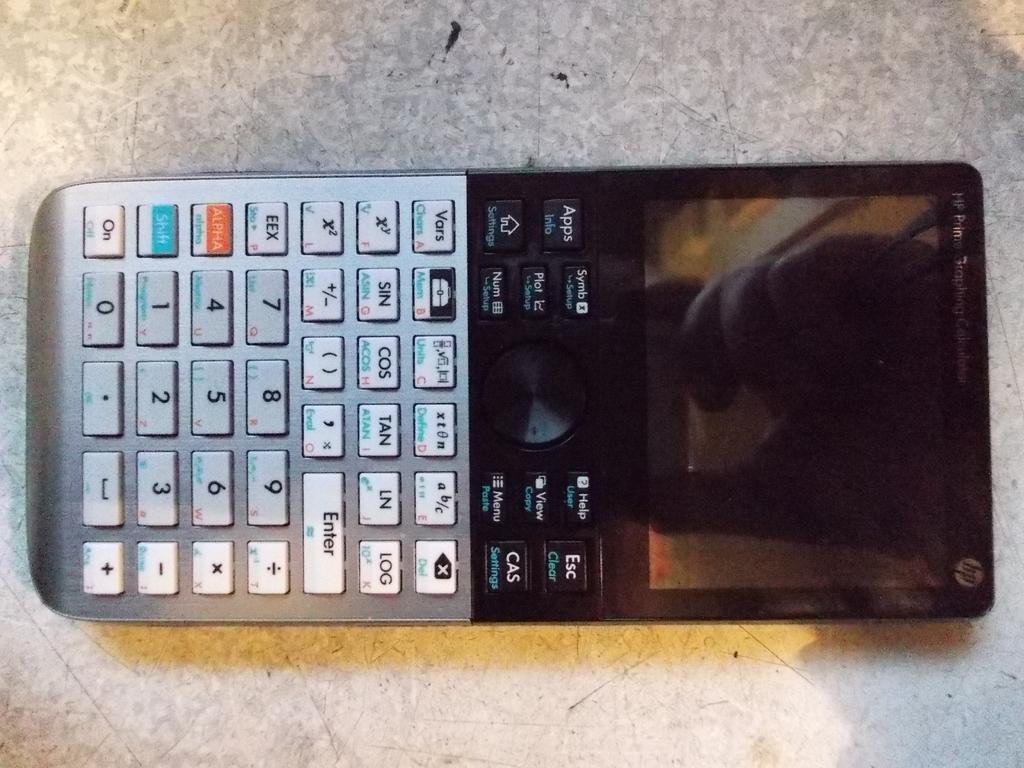<image>
Provide a brief description of the given image. An HP digital calculator is laying on a mottled surface. 